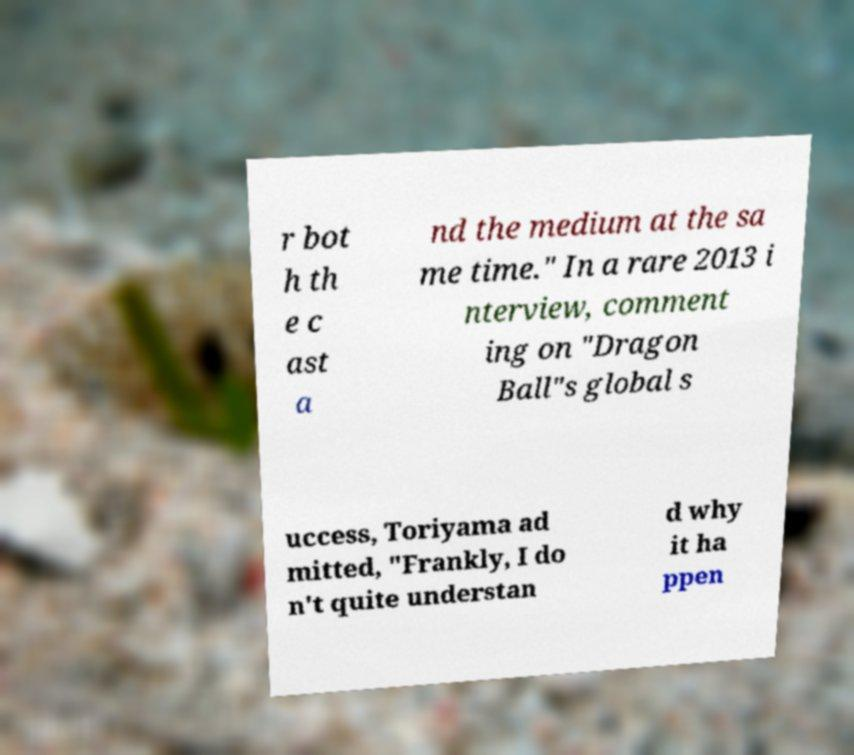Can you read and provide the text displayed in the image?This photo seems to have some interesting text. Can you extract and type it out for me? r bot h th e c ast a nd the medium at the sa me time." In a rare 2013 i nterview, comment ing on "Dragon Ball"s global s uccess, Toriyama ad mitted, "Frankly, I do n't quite understan d why it ha ppen 